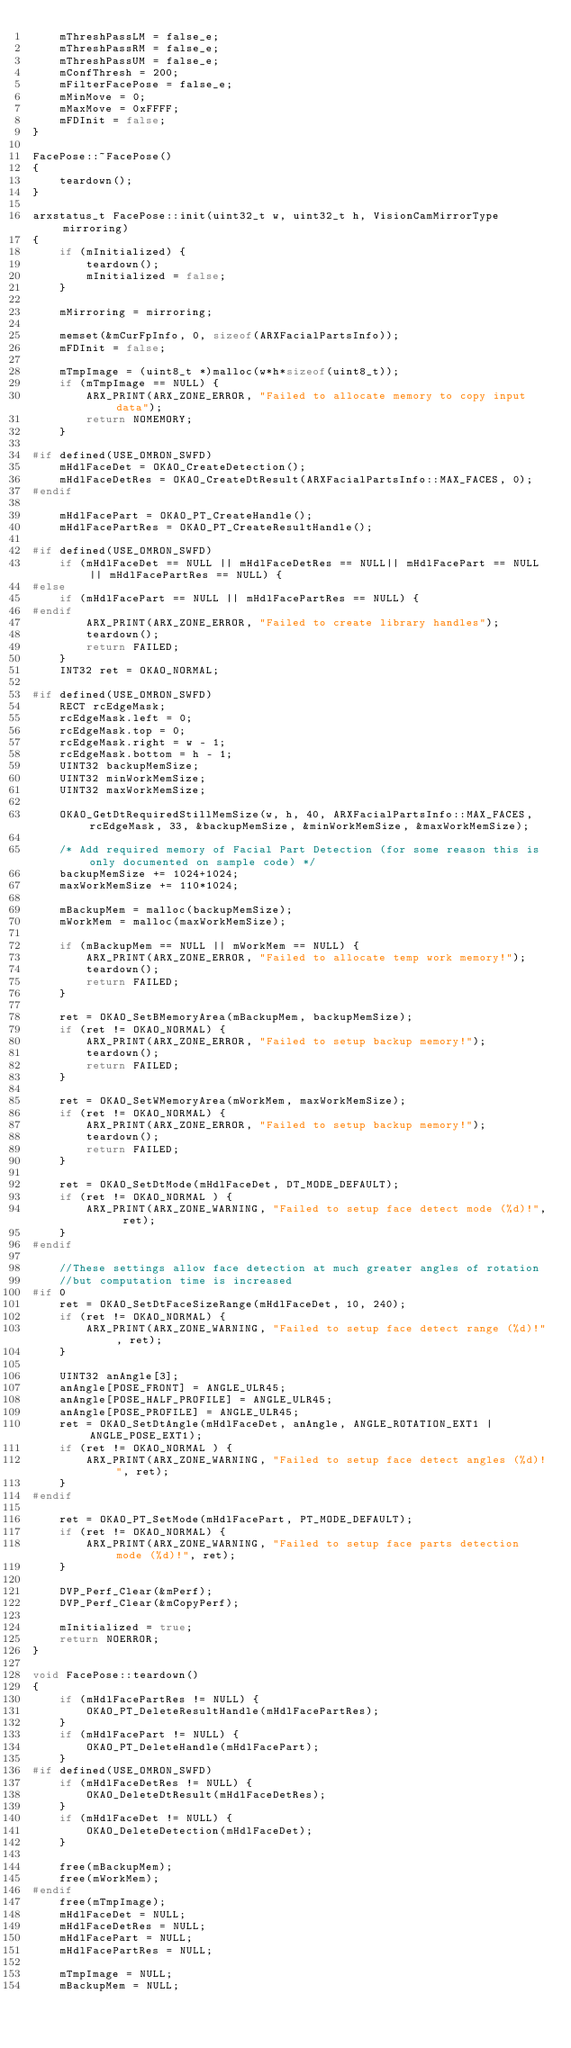Convert code to text. <code><loc_0><loc_0><loc_500><loc_500><_C++_>    mThreshPassLM = false_e;
    mThreshPassRM = false_e;
    mThreshPassUM = false_e;
    mConfThresh = 200;
    mFilterFacePose = false_e;
    mMinMove = 0;
    mMaxMove = 0xFFFF;
    mFDInit = false;
}

FacePose::~FacePose()
{
    teardown();
}

arxstatus_t FacePose::init(uint32_t w, uint32_t h, VisionCamMirrorType mirroring)
{
    if (mInitialized) {
        teardown();
        mInitialized = false;
    }

    mMirroring = mirroring;

    memset(&mCurFpInfo, 0, sizeof(ARXFacialPartsInfo));
    mFDInit = false;

    mTmpImage = (uint8_t *)malloc(w*h*sizeof(uint8_t));
    if (mTmpImage == NULL) {
        ARX_PRINT(ARX_ZONE_ERROR, "Failed to allocate memory to copy input data");
        return NOMEMORY;
    }

#if defined(USE_OMRON_SWFD)
    mHdlFaceDet = OKAO_CreateDetection();
    mHdlFaceDetRes = OKAO_CreateDtResult(ARXFacialPartsInfo::MAX_FACES, 0);
#endif

    mHdlFacePart = OKAO_PT_CreateHandle();
    mHdlFacePartRes = OKAO_PT_CreateResultHandle();

#if defined(USE_OMRON_SWFD)
    if (mHdlFaceDet == NULL || mHdlFaceDetRes == NULL|| mHdlFacePart == NULL || mHdlFacePartRes == NULL) {
#else
    if (mHdlFacePart == NULL || mHdlFacePartRes == NULL) {
#endif
        ARX_PRINT(ARX_ZONE_ERROR, "Failed to create library handles");
        teardown();
        return FAILED;
    }
    INT32 ret = OKAO_NORMAL;

#if defined(USE_OMRON_SWFD)
    RECT rcEdgeMask;
    rcEdgeMask.left = 0;
    rcEdgeMask.top = 0;
    rcEdgeMask.right = w - 1;
    rcEdgeMask.bottom = h - 1;
    UINT32 backupMemSize;
    UINT32 minWorkMemSize;
    UINT32 maxWorkMemSize;

    OKAO_GetDtRequiredStillMemSize(w, h, 40, ARXFacialPartsInfo::MAX_FACES, rcEdgeMask, 33, &backupMemSize, &minWorkMemSize, &maxWorkMemSize);

    /* Add required memory of Facial Part Detection (for some reason this is only documented on sample code) */
    backupMemSize += 1024+1024;
    maxWorkMemSize += 110*1024;

    mBackupMem = malloc(backupMemSize);
    mWorkMem = malloc(maxWorkMemSize);

    if (mBackupMem == NULL || mWorkMem == NULL) {
        ARX_PRINT(ARX_ZONE_ERROR, "Failed to allocate temp work memory!");
        teardown();
        return FAILED;
    }

    ret = OKAO_SetBMemoryArea(mBackupMem, backupMemSize);
    if (ret != OKAO_NORMAL) {
        ARX_PRINT(ARX_ZONE_ERROR, "Failed to setup backup memory!");
        teardown();
        return FAILED;
    }

    ret = OKAO_SetWMemoryArea(mWorkMem, maxWorkMemSize);
    if (ret != OKAO_NORMAL) {
        ARX_PRINT(ARX_ZONE_ERROR, "Failed to setup backup memory!");
        teardown();
        return FAILED;
    }

    ret = OKAO_SetDtMode(mHdlFaceDet, DT_MODE_DEFAULT);
    if (ret != OKAO_NORMAL ) {
        ARX_PRINT(ARX_ZONE_WARNING, "Failed to setup face detect mode (%d)!", ret);
    }
#endif

    //These settings allow face detection at much greater angles of rotation
    //but computation time is increased
#if 0
    ret = OKAO_SetDtFaceSizeRange(mHdlFaceDet, 10, 240);
    if (ret != OKAO_NORMAL) {
        ARX_PRINT(ARX_ZONE_WARNING, "Failed to setup face detect range (%d)!", ret);
    }

    UINT32 anAngle[3];
    anAngle[POSE_FRONT] = ANGLE_ULR45;
    anAngle[POSE_HALF_PROFILE] = ANGLE_ULR45;
    anAngle[POSE_PROFILE] = ANGLE_ULR45;
    ret = OKAO_SetDtAngle(mHdlFaceDet, anAngle, ANGLE_ROTATION_EXT1 | ANGLE_POSE_EXT1);
    if (ret != OKAO_NORMAL ) {
        ARX_PRINT(ARX_ZONE_WARNING, "Failed to setup face detect angles (%d)!", ret);
    }
#endif

    ret = OKAO_PT_SetMode(mHdlFacePart, PT_MODE_DEFAULT);
    if (ret != OKAO_NORMAL) {
        ARX_PRINT(ARX_ZONE_WARNING, "Failed to setup face parts detection mode (%d)!", ret);
    }

    DVP_Perf_Clear(&mPerf);
    DVP_Perf_Clear(&mCopyPerf);

    mInitialized = true;
    return NOERROR;
}

void FacePose::teardown()
{
    if (mHdlFacePartRes != NULL) {
        OKAO_PT_DeleteResultHandle(mHdlFacePartRes);
    }
    if (mHdlFacePart != NULL) {
        OKAO_PT_DeleteHandle(mHdlFacePart);
    }
#if defined(USE_OMRON_SWFD)
    if (mHdlFaceDetRes != NULL) {
        OKAO_DeleteDtResult(mHdlFaceDetRes);
    }
    if (mHdlFaceDet != NULL) {
        OKAO_DeleteDetection(mHdlFaceDet);
    }

    free(mBackupMem);
    free(mWorkMem);
#endif
    free(mTmpImage);
    mHdlFaceDet = NULL;
    mHdlFaceDetRes = NULL;
    mHdlFacePart = NULL;
    mHdlFacePartRes = NULL;

    mTmpImage = NULL;
    mBackupMem = NULL;</code> 